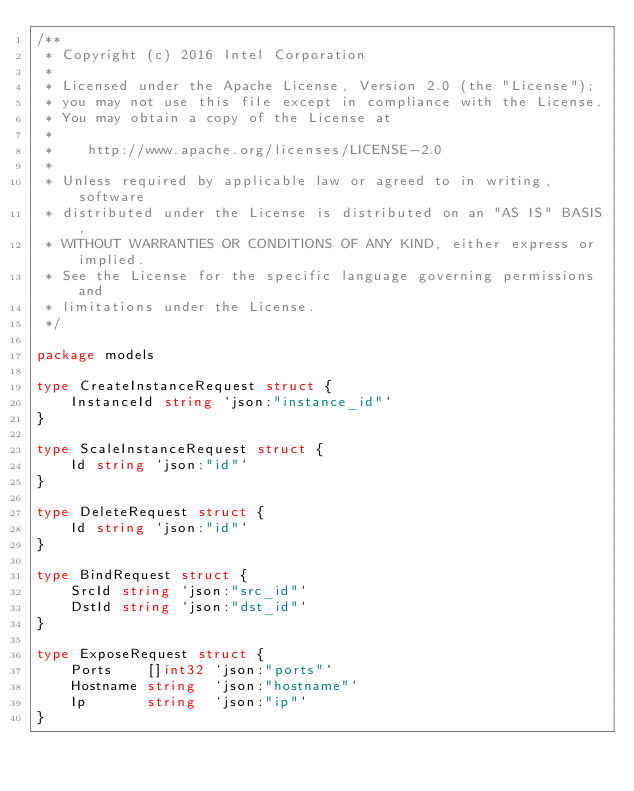<code> <loc_0><loc_0><loc_500><loc_500><_Go_>/**
 * Copyright (c) 2016 Intel Corporation
 *
 * Licensed under the Apache License, Version 2.0 (the "License");
 * you may not use this file except in compliance with the License.
 * You may obtain a copy of the License at
 *
 *    http://www.apache.org/licenses/LICENSE-2.0
 *
 * Unless required by applicable law or agreed to in writing, software
 * distributed under the License is distributed on an "AS IS" BASIS,
 * WITHOUT WARRANTIES OR CONDITIONS OF ANY KIND, either express or implied.
 * See the License for the specific language governing permissions and
 * limitations under the License.
 */

package models

type CreateInstanceRequest struct {
	InstanceId string `json:"instance_id"`
}

type ScaleInstanceRequest struct {
	Id string `json:"id"`
}

type DeleteRequest struct {
	Id string `json:"id"`
}

type BindRequest struct {
	SrcId string `json:"src_id"`
	DstId string `json:"dst_id"`
}

type ExposeRequest struct {
	Ports    []int32 `json:"ports"`
	Hostname string  `json:"hostname"`
	Ip       string  `json:"ip"`
}
</code> 